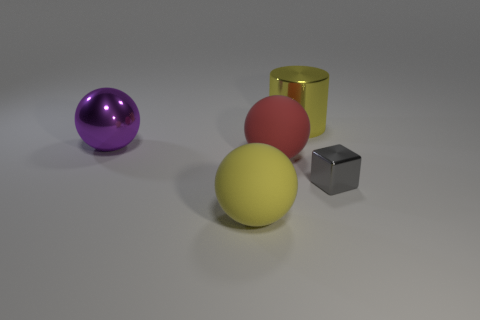How many large things are balls or cylinders?
Your answer should be compact. 4. Do the shiny thing behind the purple metal object and the purple shiny object have the same size?
Provide a succinct answer. Yes. How many other objects are there of the same color as the metal cylinder?
Ensure brevity in your answer.  1. What is the material of the gray block?
Your response must be concise. Metal. There is a object that is both behind the red thing and on the right side of the big purple sphere; what is its material?
Offer a very short reply. Metal. What number of things are big things behind the cube or tiny green rubber cylinders?
Your answer should be compact. 3. Is there a matte ball of the same size as the yellow metallic object?
Keep it short and to the point. Yes. How many big things are both right of the yellow matte ball and in front of the big yellow cylinder?
Ensure brevity in your answer.  1. How many yellow rubber spheres are on the left side of the yellow sphere?
Give a very brief answer. 0. Is there another large purple thing of the same shape as the big purple object?
Your answer should be compact. No. 